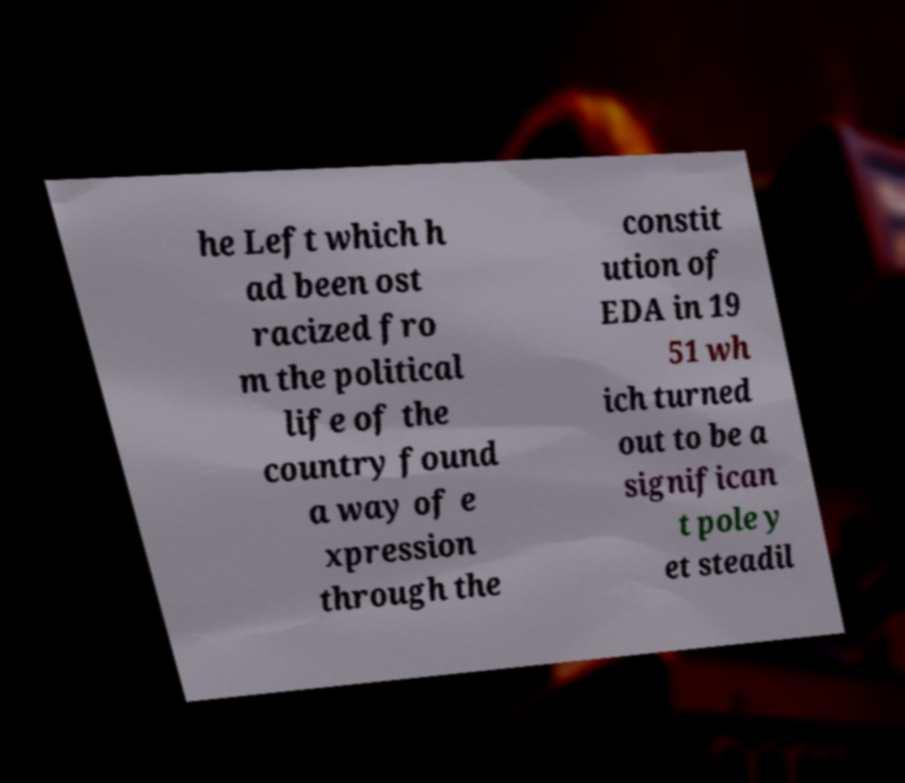Can you accurately transcribe the text from the provided image for me? he Left which h ad been ost racized fro m the political life of the country found a way of e xpression through the constit ution of EDA in 19 51 wh ich turned out to be a significan t pole y et steadil 